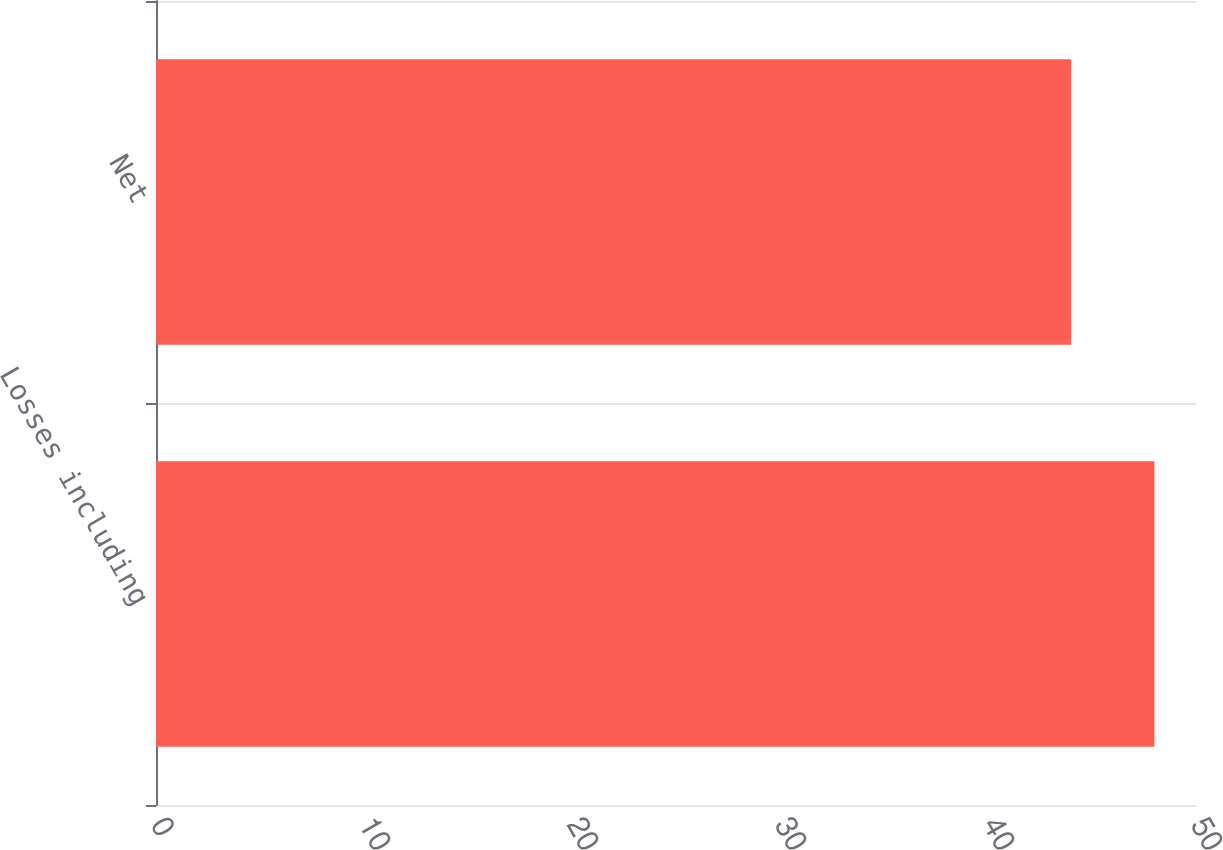<chart> <loc_0><loc_0><loc_500><loc_500><bar_chart><fcel>Losses including<fcel>Net<nl><fcel>48<fcel>44<nl></chart> 